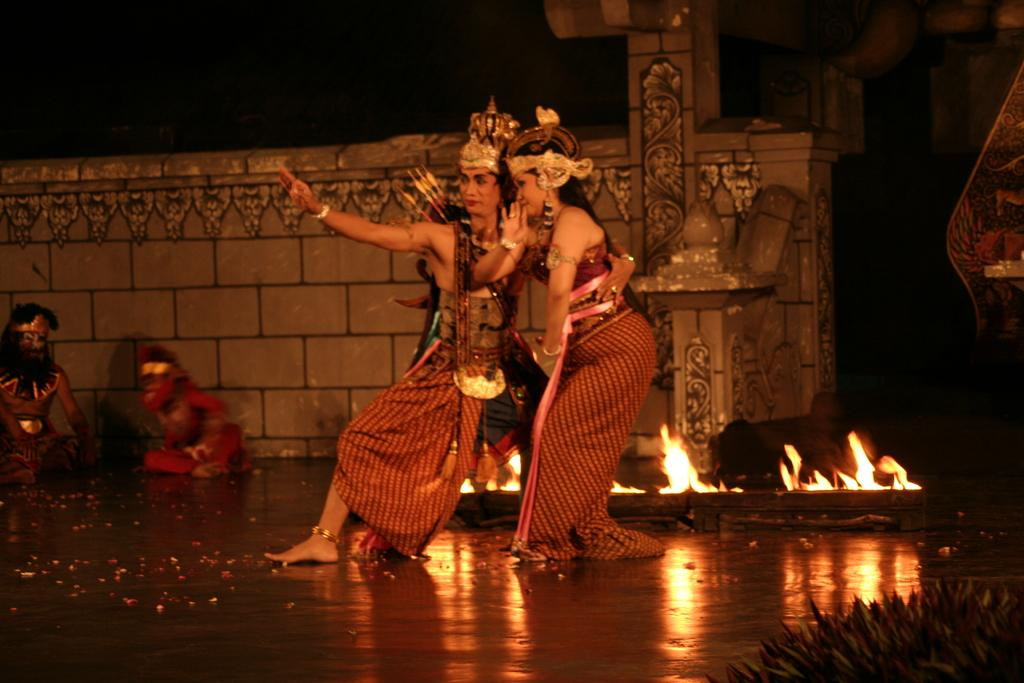What are the people in the image doing? The people are performing an act in the image. What can be seen in the background of the image? There is a fire and a wall visible in the background of the image. What type of bird is perched on the wrist of one of the performers in the image? There is no bird present on the wrist of any performer in the image. 